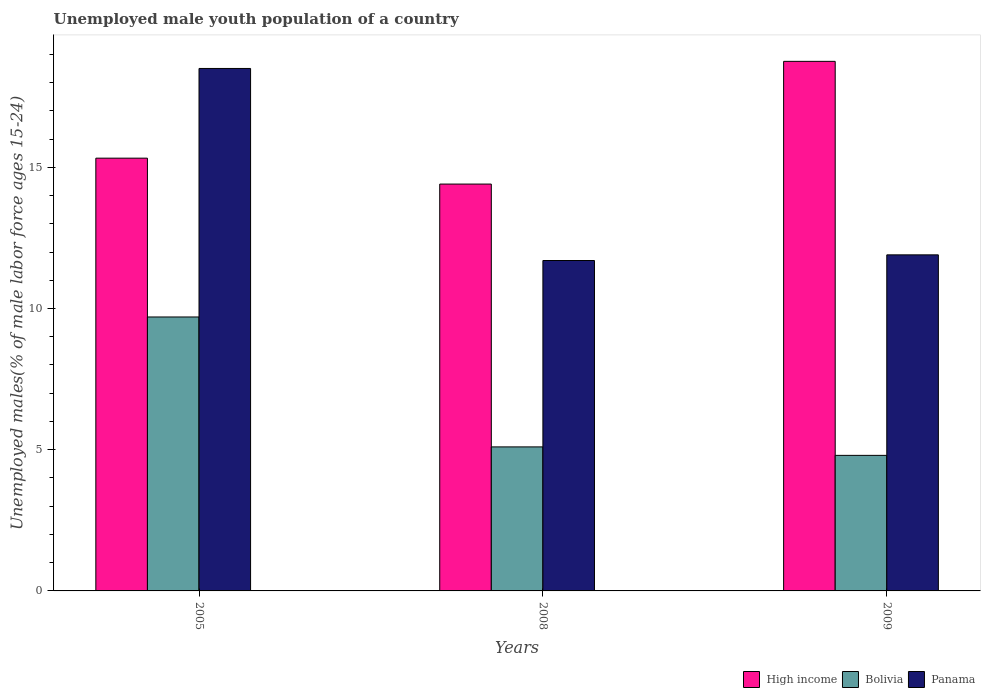How many bars are there on the 2nd tick from the right?
Offer a terse response. 3. What is the percentage of unemployed male youth population in High income in 2008?
Offer a terse response. 14.41. Across all years, what is the maximum percentage of unemployed male youth population in Panama?
Your answer should be very brief. 18.5. Across all years, what is the minimum percentage of unemployed male youth population in High income?
Provide a short and direct response. 14.41. What is the total percentage of unemployed male youth population in Bolivia in the graph?
Your response must be concise. 19.6. What is the difference between the percentage of unemployed male youth population in Bolivia in 2008 and that in 2009?
Give a very brief answer. 0.3. What is the difference between the percentage of unemployed male youth population in Panama in 2008 and the percentage of unemployed male youth population in Bolivia in 2005?
Provide a short and direct response. 2. What is the average percentage of unemployed male youth population in High income per year?
Ensure brevity in your answer.  16.16. In the year 2008, what is the difference between the percentage of unemployed male youth population in Panama and percentage of unemployed male youth population in Bolivia?
Keep it short and to the point. 6.6. What is the ratio of the percentage of unemployed male youth population in High income in 2005 to that in 2009?
Your response must be concise. 0.82. What is the difference between the highest and the second highest percentage of unemployed male youth population in High income?
Your answer should be very brief. 3.43. What is the difference between the highest and the lowest percentage of unemployed male youth population in Bolivia?
Your answer should be compact. 4.9. In how many years, is the percentage of unemployed male youth population in Panama greater than the average percentage of unemployed male youth population in Panama taken over all years?
Provide a short and direct response. 1. What does the 3rd bar from the left in 2005 represents?
Your answer should be very brief. Panama. What does the 3rd bar from the right in 2009 represents?
Offer a terse response. High income. Are all the bars in the graph horizontal?
Your answer should be very brief. No. How many years are there in the graph?
Provide a succinct answer. 3. Are the values on the major ticks of Y-axis written in scientific E-notation?
Your response must be concise. No. Does the graph contain grids?
Ensure brevity in your answer.  No. How many legend labels are there?
Provide a short and direct response. 3. What is the title of the graph?
Ensure brevity in your answer.  Unemployed male youth population of a country. What is the label or title of the Y-axis?
Give a very brief answer. Unemployed males(% of male labor force ages 15-24). What is the Unemployed males(% of male labor force ages 15-24) in High income in 2005?
Give a very brief answer. 15.32. What is the Unemployed males(% of male labor force ages 15-24) of Bolivia in 2005?
Give a very brief answer. 9.7. What is the Unemployed males(% of male labor force ages 15-24) of High income in 2008?
Your response must be concise. 14.41. What is the Unemployed males(% of male labor force ages 15-24) of Bolivia in 2008?
Ensure brevity in your answer.  5.1. What is the Unemployed males(% of male labor force ages 15-24) of Panama in 2008?
Provide a short and direct response. 11.7. What is the Unemployed males(% of male labor force ages 15-24) of High income in 2009?
Your response must be concise. 18.75. What is the Unemployed males(% of male labor force ages 15-24) in Bolivia in 2009?
Provide a succinct answer. 4.8. What is the Unemployed males(% of male labor force ages 15-24) in Panama in 2009?
Offer a very short reply. 11.9. Across all years, what is the maximum Unemployed males(% of male labor force ages 15-24) of High income?
Offer a terse response. 18.75. Across all years, what is the maximum Unemployed males(% of male labor force ages 15-24) of Bolivia?
Offer a very short reply. 9.7. Across all years, what is the maximum Unemployed males(% of male labor force ages 15-24) of Panama?
Make the answer very short. 18.5. Across all years, what is the minimum Unemployed males(% of male labor force ages 15-24) of High income?
Ensure brevity in your answer.  14.41. Across all years, what is the minimum Unemployed males(% of male labor force ages 15-24) of Bolivia?
Your answer should be compact. 4.8. Across all years, what is the minimum Unemployed males(% of male labor force ages 15-24) in Panama?
Give a very brief answer. 11.7. What is the total Unemployed males(% of male labor force ages 15-24) in High income in the graph?
Your response must be concise. 48.48. What is the total Unemployed males(% of male labor force ages 15-24) in Bolivia in the graph?
Make the answer very short. 19.6. What is the total Unemployed males(% of male labor force ages 15-24) of Panama in the graph?
Your answer should be very brief. 42.1. What is the difference between the Unemployed males(% of male labor force ages 15-24) of High income in 2005 and that in 2008?
Keep it short and to the point. 0.92. What is the difference between the Unemployed males(% of male labor force ages 15-24) of High income in 2005 and that in 2009?
Give a very brief answer. -3.43. What is the difference between the Unemployed males(% of male labor force ages 15-24) in Panama in 2005 and that in 2009?
Your answer should be compact. 6.6. What is the difference between the Unemployed males(% of male labor force ages 15-24) of High income in 2008 and that in 2009?
Make the answer very short. -4.35. What is the difference between the Unemployed males(% of male labor force ages 15-24) in Bolivia in 2008 and that in 2009?
Make the answer very short. 0.3. What is the difference between the Unemployed males(% of male labor force ages 15-24) of High income in 2005 and the Unemployed males(% of male labor force ages 15-24) of Bolivia in 2008?
Keep it short and to the point. 10.22. What is the difference between the Unemployed males(% of male labor force ages 15-24) in High income in 2005 and the Unemployed males(% of male labor force ages 15-24) in Panama in 2008?
Make the answer very short. 3.62. What is the difference between the Unemployed males(% of male labor force ages 15-24) in High income in 2005 and the Unemployed males(% of male labor force ages 15-24) in Bolivia in 2009?
Your answer should be very brief. 10.52. What is the difference between the Unemployed males(% of male labor force ages 15-24) of High income in 2005 and the Unemployed males(% of male labor force ages 15-24) of Panama in 2009?
Provide a short and direct response. 3.42. What is the difference between the Unemployed males(% of male labor force ages 15-24) of Bolivia in 2005 and the Unemployed males(% of male labor force ages 15-24) of Panama in 2009?
Keep it short and to the point. -2.2. What is the difference between the Unemployed males(% of male labor force ages 15-24) in High income in 2008 and the Unemployed males(% of male labor force ages 15-24) in Bolivia in 2009?
Your response must be concise. 9.61. What is the difference between the Unemployed males(% of male labor force ages 15-24) in High income in 2008 and the Unemployed males(% of male labor force ages 15-24) in Panama in 2009?
Your answer should be very brief. 2.51. What is the average Unemployed males(% of male labor force ages 15-24) of High income per year?
Keep it short and to the point. 16.16. What is the average Unemployed males(% of male labor force ages 15-24) of Bolivia per year?
Keep it short and to the point. 6.53. What is the average Unemployed males(% of male labor force ages 15-24) in Panama per year?
Your response must be concise. 14.03. In the year 2005, what is the difference between the Unemployed males(% of male labor force ages 15-24) of High income and Unemployed males(% of male labor force ages 15-24) of Bolivia?
Make the answer very short. 5.62. In the year 2005, what is the difference between the Unemployed males(% of male labor force ages 15-24) in High income and Unemployed males(% of male labor force ages 15-24) in Panama?
Provide a succinct answer. -3.18. In the year 2008, what is the difference between the Unemployed males(% of male labor force ages 15-24) in High income and Unemployed males(% of male labor force ages 15-24) in Bolivia?
Provide a succinct answer. 9.31. In the year 2008, what is the difference between the Unemployed males(% of male labor force ages 15-24) in High income and Unemployed males(% of male labor force ages 15-24) in Panama?
Give a very brief answer. 2.71. In the year 2009, what is the difference between the Unemployed males(% of male labor force ages 15-24) of High income and Unemployed males(% of male labor force ages 15-24) of Bolivia?
Your response must be concise. 13.95. In the year 2009, what is the difference between the Unemployed males(% of male labor force ages 15-24) of High income and Unemployed males(% of male labor force ages 15-24) of Panama?
Your answer should be compact. 6.85. In the year 2009, what is the difference between the Unemployed males(% of male labor force ages 15-24) of Bolivia and Unemployed males(% of male labor force ages 15-24) of Panama?
Give a very brief answer. -7.1. What is the ratio of the Unemployed males(% of male labor force ages 15-24) of High income in 2005 to that in 2008?
Offer a very short reply. 1.06. What is the ratio of the Unemployed males(% of male labor force ages 15-24) of Bolivia in 2005 to that in 2008?
Offer a terse response. 1.9. What is the ratio of the Unemployed males(% of male labor force ages 15-24) in Panama in 2005 to that in 2008?
Your answer should be compact. 1.58. What is the ratio of the Unemployed males(% of male labor force ages 15-24) of High income in 2005 to that in 2009?
Offer a terse response. 0.82. What is the ratio of the Unemployed males(% of male labor force ages 15-24) in Bolivia in 2005 to that in 2009?
Keep it short and to the point. 2.02. What is the ratio of the Unemployed males(% of male labor force ages 15-24) of Panama in 2005 to that in 2009?
Your response must be concise. 1.55. What is the ratio of the Unemployed males(% of male labor force ages 15-24) of High income in 2008 to that in 2009?
Offer a terse response. 0.77. What is the ratio of the Unemployed males(% of male labor force ages 15-24) of Bolivia in 2008 to that in 2009?
Make the answer very short. 1.06. What is the ratio of the Unemployed males(% of male labor force ages 15-24) in Panama in 2008 to that in 2009?
Keep it short and to the point. 0.98. What is the difference between the highest and the second highest Unemployed males(% of male labor force ages 15-24) in High income?
Ensure brevity in your answer.  3.43. What is the difference between the highest and the second highest Unemployed males(% of male labor force ages 15-24) in Bolivia?
Offer a terse response. 4.6. What is the difference between the highest and the lowest Unemployed males(% of male labor force ages 15-24) in High income?
Give a very brief answer. 4.35. What is the difference between the highest and the lowest Unemployed males(% of male labor force ages 15-24) of Bolivia?
Your answer should be very brief. 4.9. 